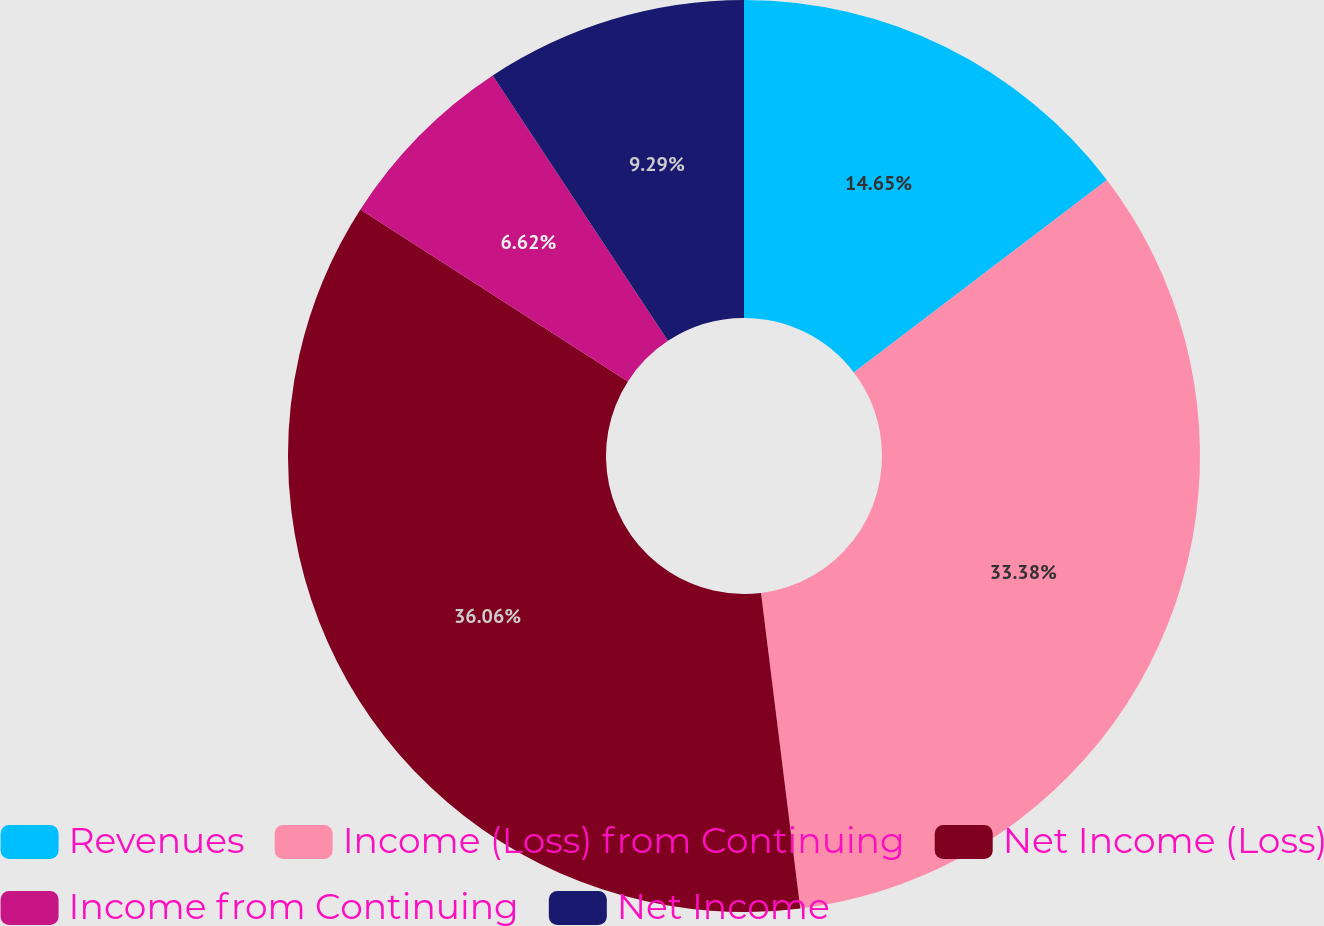Convert chart to OTSL. <chart><loc_0><loc_0><loc_500><loc_500><pie_chart><fcel>Revenues<fcel>Income (Loss) from Continuing<fcel>Net Income (Loss)<fcel>Income from Continuing<fcel>Net Income<nl><fcel>14.65%<fcel>33.38%<fcel>36.06%<fcel>6.62%<fcel>9.29%<nl></chart> 